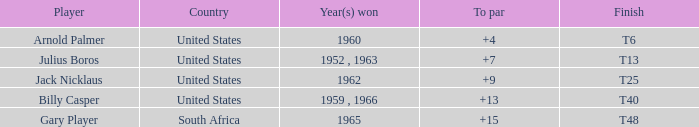What was the maximum total score gary player reached when his to par was above 15? None. 